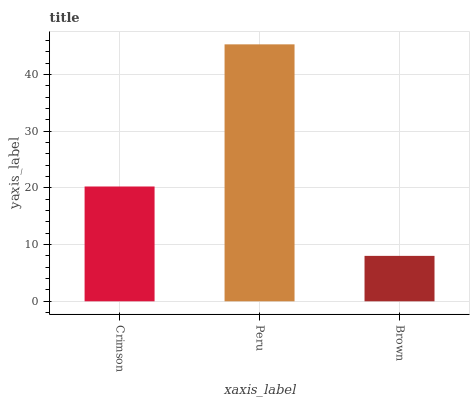Is Peru the minimum?
Answer yes or no. No. Is Brown the maximum?
Answer yes or no. No. Is Peru greater than Brown?
Answer yes or no. Yes. Is Brown less than Peru?
Answer yes or no. Yes. Is Brown greater than Peru?
Answer yes or no. No. Is Peru less than Brown?
Answer yes or no. No. Is Crimson the high median?
Answer yes or no. Yes. Is Crimson the low median?
Answer yes or no. Yes. Is Brown the high median?
Answer yes or no. No. Is Brown the low median?
Answer yes or no. No. 